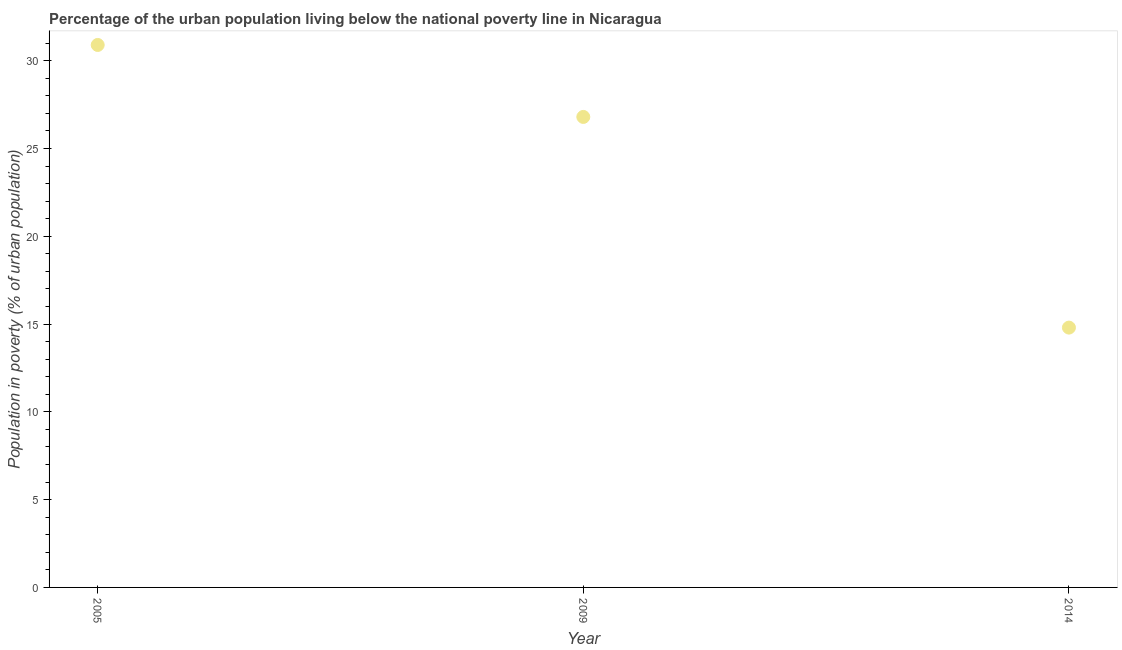What is the percentage of urban population living below poverty line in 2009?
Make the answer very short. 26.8. Across all years, what is the maximum percentage of urban population living below poverty line?
Provide a succinct answer. 30.9. Across all years, what is the minimum percentage of urban population living below poverty line?
Your answer should be very brief. 14.8. In which year was the percentage of urban population living below poverty line maximum?
Offer a terse response. 2005. What is the sum of the percentage of urban population living below poverty line?
Your answer should be compact. 72.5. What is the difference between the percentage of urban population living below poverty line in 2005 and 2014?
Your response must be concise. 16.1. What is the average percentage of urban population living below poverty line per year?
Your answer should be very brief. 24.17. What is the median percentage of urban population living below poverty line?
Provide a succinct answer. 26.8. In how many years, is the percentage of urban population living below poverty line greater than 2 %?
Your answer should be compact. 3. Do a majority of the years between 2009 and 2014 (inclusive) have percentage of urban population living below poverty line greater than 18 %?
Provide a short and direct response. No. What is the ratio of the percentage of urban population living below poverty line in 2005 to that in 2014?
Keep it short and to the point. 2.09. Is the percentage of urban population living below poverty line in 2005 less than that in 2014?
Provide a short and direct response. No. What is the difference between the highest and the second highest percentage of urban population living below poverty line?
Provide a short and direct response. 4.1. What is the difference between the highest and the lowest percentage of urban population living below poverty line?
Give a very brief answer. 16.1. Does the percentage of urban population living below poverty line monotonically increase over the years?
Your response must be concise. No. How many years are there in the graph?
Offer a very short reply. 3. What is the difference between two consecutive major ticks on the Y-axis?
Keep it short and to the point. 5. Are the values on the major ticks of Y-axis written in scientific E-notation?
Your answer should be compact. No. Does the graph contain any zero values?
Provide a short and direct response. No. What is the title of the graph?
Give a very brief answer. Percentage of the urban population living below the national poverty line in Nicaragua. What is the label or title of the Y-axis?
Your response must be concise. Population in poverty (% of urban population). What is the Population in poverty (% of urban population) in 2005?
Keep it short and to the point. 30.9. What is the Population in poverty (% of urban population) in 2009?
Keep it short and to the point. 26.8. What is the difference between the Population in poverty (% of urban population) in 2005 and 2009?
Keep it short and to the point. 4.1. What is the difference between the Population in poverty (% of urban population) in 2005 and 2014?
Provide a short and direct response. 16.1. What is the difference between the Population in poverty (% of urban population) in 2009 and 2014?
Ensure brevity in your answer.  12. What is the ratio of the Population in poverty (% of urban population) in 2005 to that in 2009?
Make the answer very short. 1.15. What is the ratio of the Population in poverty (% of urban population) in 2005 to that in 2014?
Make the answer very short. 2.09. What is the ratio of the Population in poverty (% of urban population) in 2009 to that in 2014?
Your response must be concise. 1.81. 